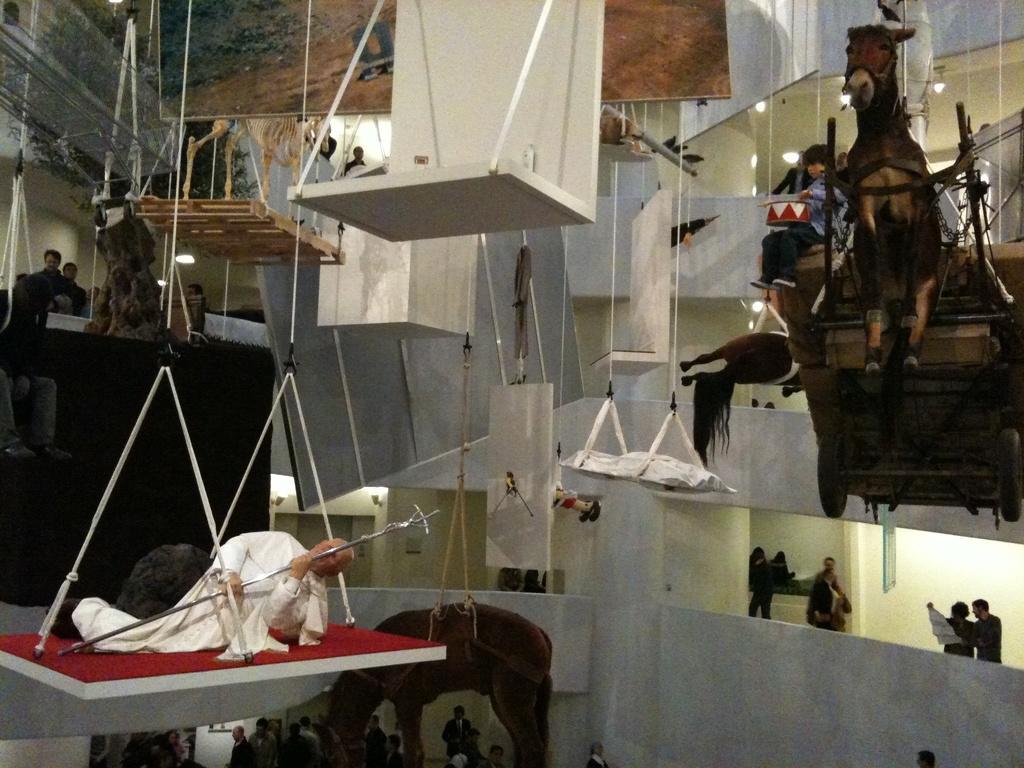Can you describe this image briefly? This is the picture of a place where we have some people and a horse on the hanging, which are hanged to the roof and also we can see some other people and other things around. 